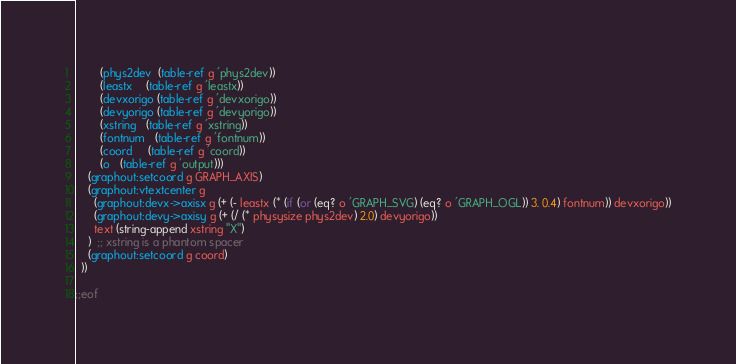Convert code to text. <code><loc_0><loc_0><loc_500><loc_500><_Scheme_>        (phys2dev  (table-ref g 'phys2dev))
        (leastx    (table-ref g 'leastx))
        (devxorigo (table-ref g 'devxorigo))
        (devyorigo (table-ref g 'devyorigo))
        (xstring   (table-ref g 'xstring))
        (fontnum   (table-ref g 'fontnum))
        (coord     (table-ref g 'coord))
        (o   (table-ref g 'output)))
    (graphout:setcoord g GRAPH_AXIS)
    (graphout:vtextcenter g
      (graphout:devx->axisx g (+ (- leastx (* (if (or (eq? o 'GRAPH_SVG) (eq? o 'GRAPH_OGL)) 3. 0.4) fontnum)) devxorigo))
      (graphout:devy->axisy g (+ (/ (* physysize phys2dev) 2.0) devyorigo))
      text (string-append xstring "X")
    )  ;; xstring is a phantom spacer
    (graphout:setcoord g coord)
  ))

;;eof
</code> 